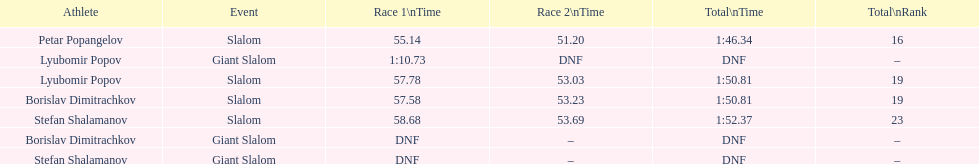How many athletes are there total? 4. 